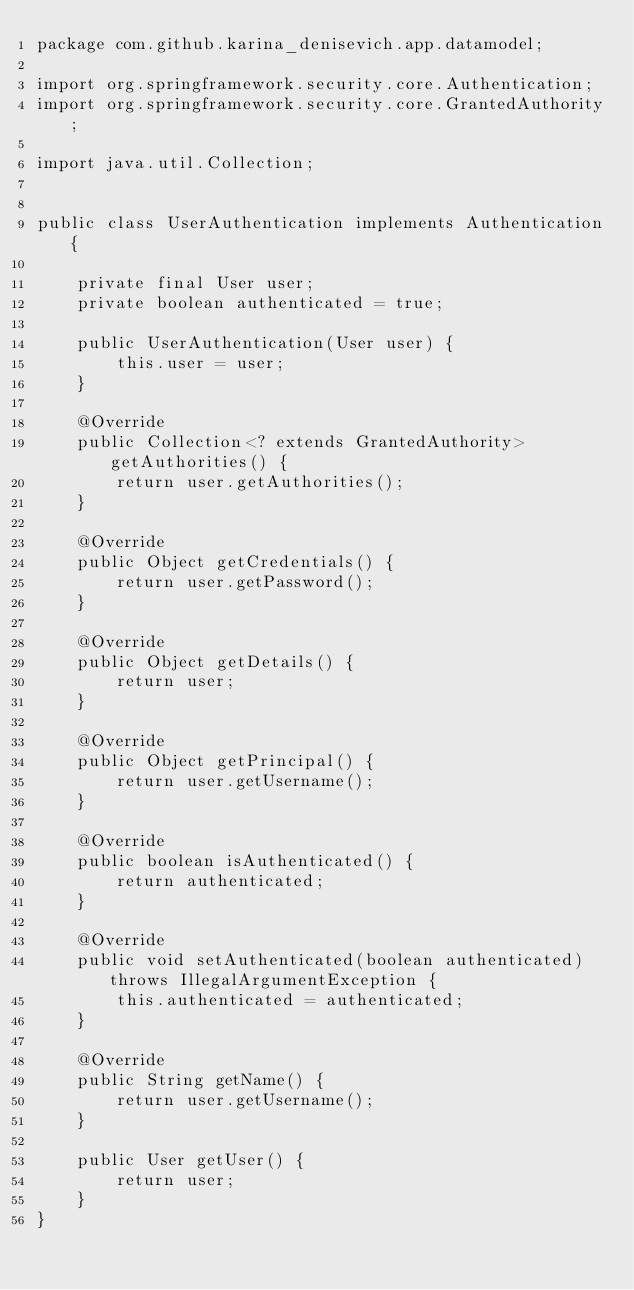<code> <loc_0><loc_0><loc_500><loc_500><_Java_>package com.github.karina_denisevich.app.datamodel;

import org.springframework.security.core.Authentication;
import org.springframework.security.core.GrantedAuthority;

import java.util.Collection;


public class UserAuthentication implements Authentication{

    private final User user;
    private boolean authenticated = true;

    public UserAuthentication(User user) {
        this.user = user;
    }

    @Override
    public Collection<? extends GrantedAuthority> getAuthorities() {
        return user.getAuthorities();
    }

    @Override
    public Object getCredentials() {
        return user.getPassword();
    }

    @Override
    public Object getDetails() {
        return user;
    }

    @Override
    public Object getPrincipal() {
        return user.getUsername();
    }

    @Override
    public boolean isAuthenticated() {
        return authenticated;
    }

    @Override
    public void setAuthenticated(boolean authenticated) throws IllegalArgumentException {
        this.authenticated = authenticated;
    }

    @Override
    public String getName() {
        return user.getUsername();
    }

    public User getUser() {
        return user;
    }
}
</code> 